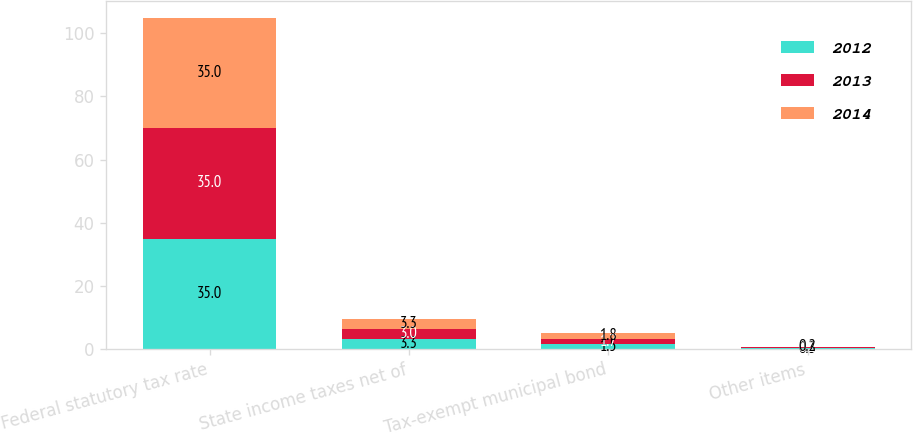Convert chart to OTSL. <chart><loc_0><loc_0><loc_500><loc_500><stacked_bar_chart><ecel><fcel>Federal statutory tax rate<fcel>State income taxes net of<fcel>Tax-exempt municipal bond<fcel>Other items<nl><fcel>2012<fcel>35<fcel>3.3<fcel>1.5<fcel>0.3<nl><fcel>2013<fcel>35<fcel>3<fcel>1.7<fcel>0.2<nl><fcel>2014<fcel>35<fcel>3.3<fcel>1.8<fcel>0.2<nl></chart> 